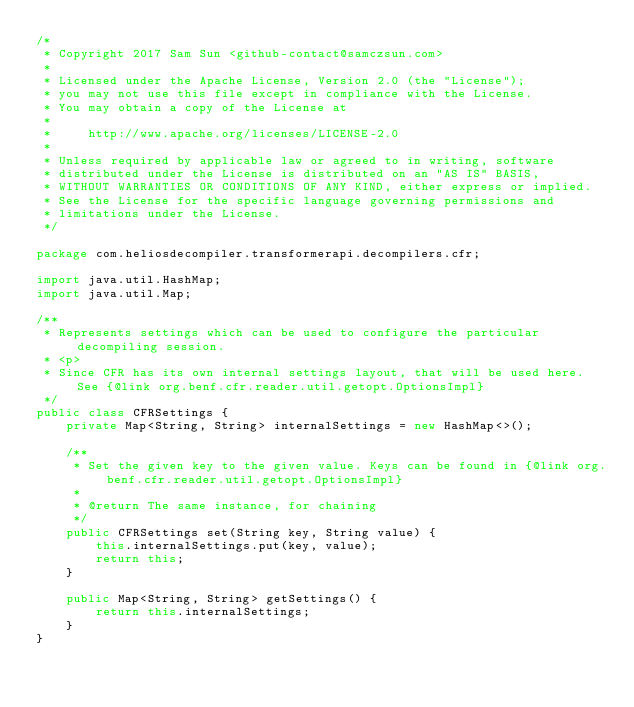Convert code to text. <code><loc_0><loc_0><loc_500><loc_500><_Java_>/*
 * Copyright 2017 Sam Sun <github-contact@samczsun.com>
 *
 * Licensed under the Apache License, Version 2.0 (the "License");
 * you may not use this file except in compliance with the License.
 * You may obtain a copy of the License at
 *
 *     http://www.apache.org/licenses/LICENSE-2.0
 *
 * Unless required by applicable law or agreed to in writing, software
 * distributed under the License is distributed on an "AS IS" BASIS,
 * WITHOUT WARRANTIES OR CONDITIONS OF ANY KIND, either express or implied.
 * See the License for the specific language governing permissions and
 * limitations under the License.
 */

package com.heliosdecompiler.transformerapi.decompilers.cfr;

import java.util.HashMap;
import java.util.Map;

/**
 * Represents settings which can be used to configure the particular decompiling session.
 * <p>
 * Since CFR has its own internal settings layout, that will be used here. See {@link org.benf.cfr.reader.util.getopt.OptionsImpl}
 */
public class CFRSettings {
    private Map<String, String> internalSettings = new HashMap<>();

    /**
     * Set the given key to the given value. Keys can be found in {@link org.benf.cfr.reader.util.getopt.OptionsImpl}
     *
     * @return The same instance, for chaining
     */
    public CFRSettings set(String key, String value) {
        this.internalSettings.put(key, value);
        return this;
    }

    public Map<String, String> getSettings() {
        return this.internalSettings;
    }
}
</code> 